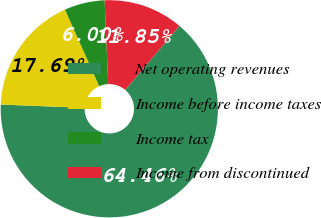Convert chart to OTSL. <chart><loc_0><loc_0><loc_500><loc_500><pie_chart><fcel>Net operating revenues<fcel>Income before income taxes<fcel>Income tax<fcel>Income from discontinued<nl><fcel>64.45%<fcel>17.69%<fcel>6.0%<fcel>11.85%<nl></chart> 